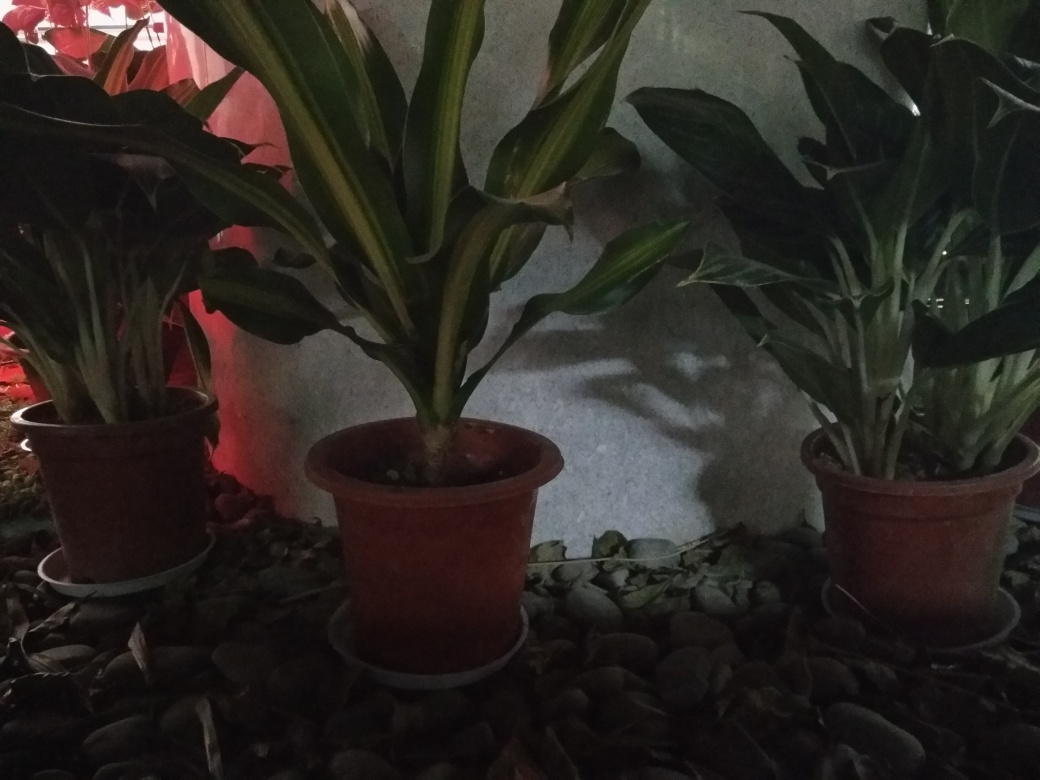Is the quality of this photo acceptable?
A. Unsure
B. Undecided
C. Yes
Answer with the option's letter from the given choices directly.
 C. 